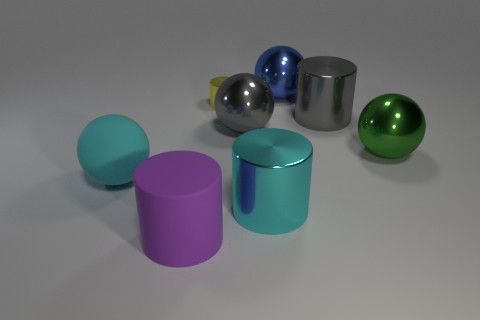Add 2 large gray metal things. How many objects exist? 10 Subtract 0 green cubes. How many objects are left? 8 Subtract all red rubber cubes. Subtract all purple matte cylinders. How many objects are left? 7 Add 8 matte cylinders. How many matte cylinders are left? 9 Add 3 tiny yellow cylinders. How many tiny yellow cylinders exist? 4 